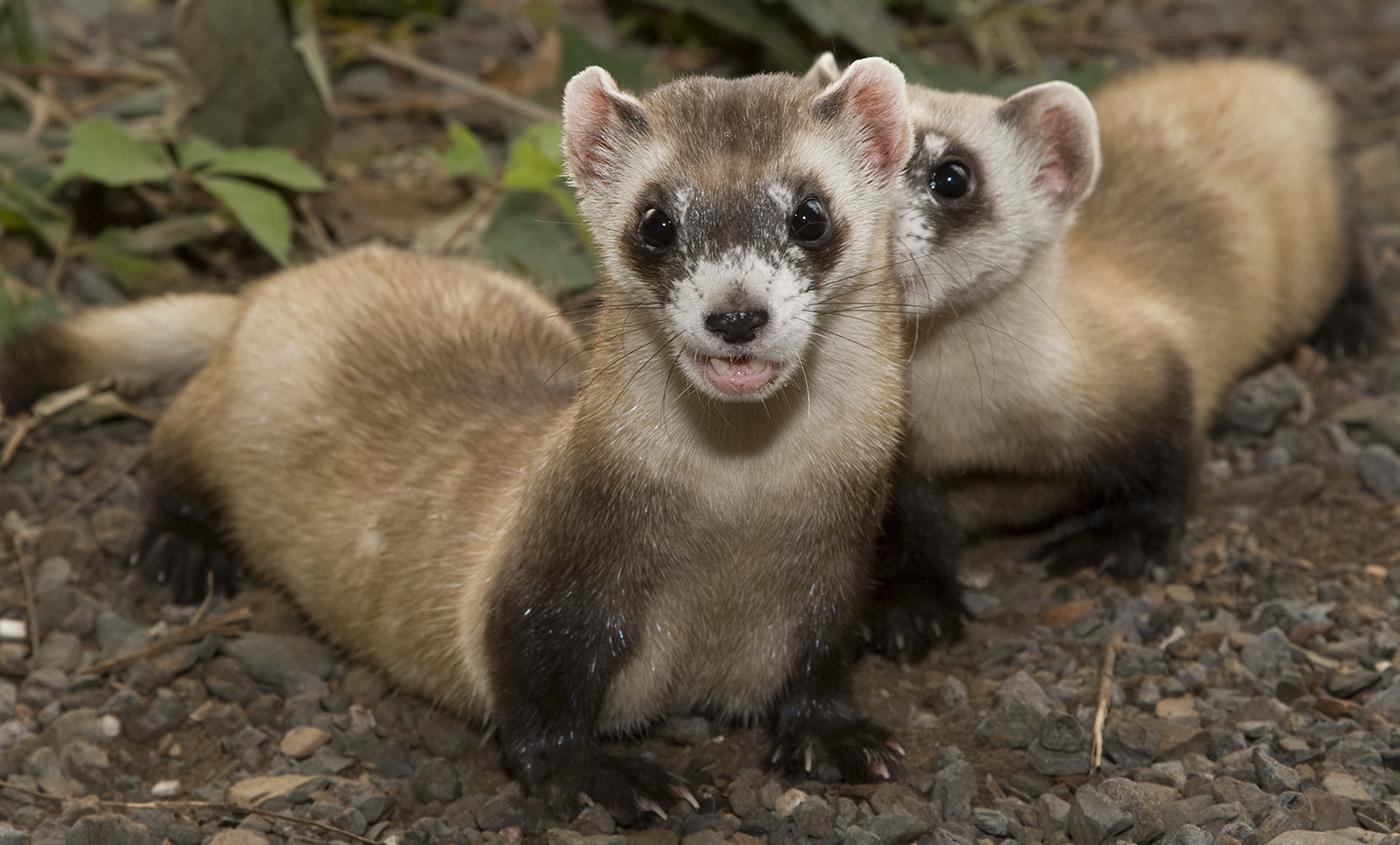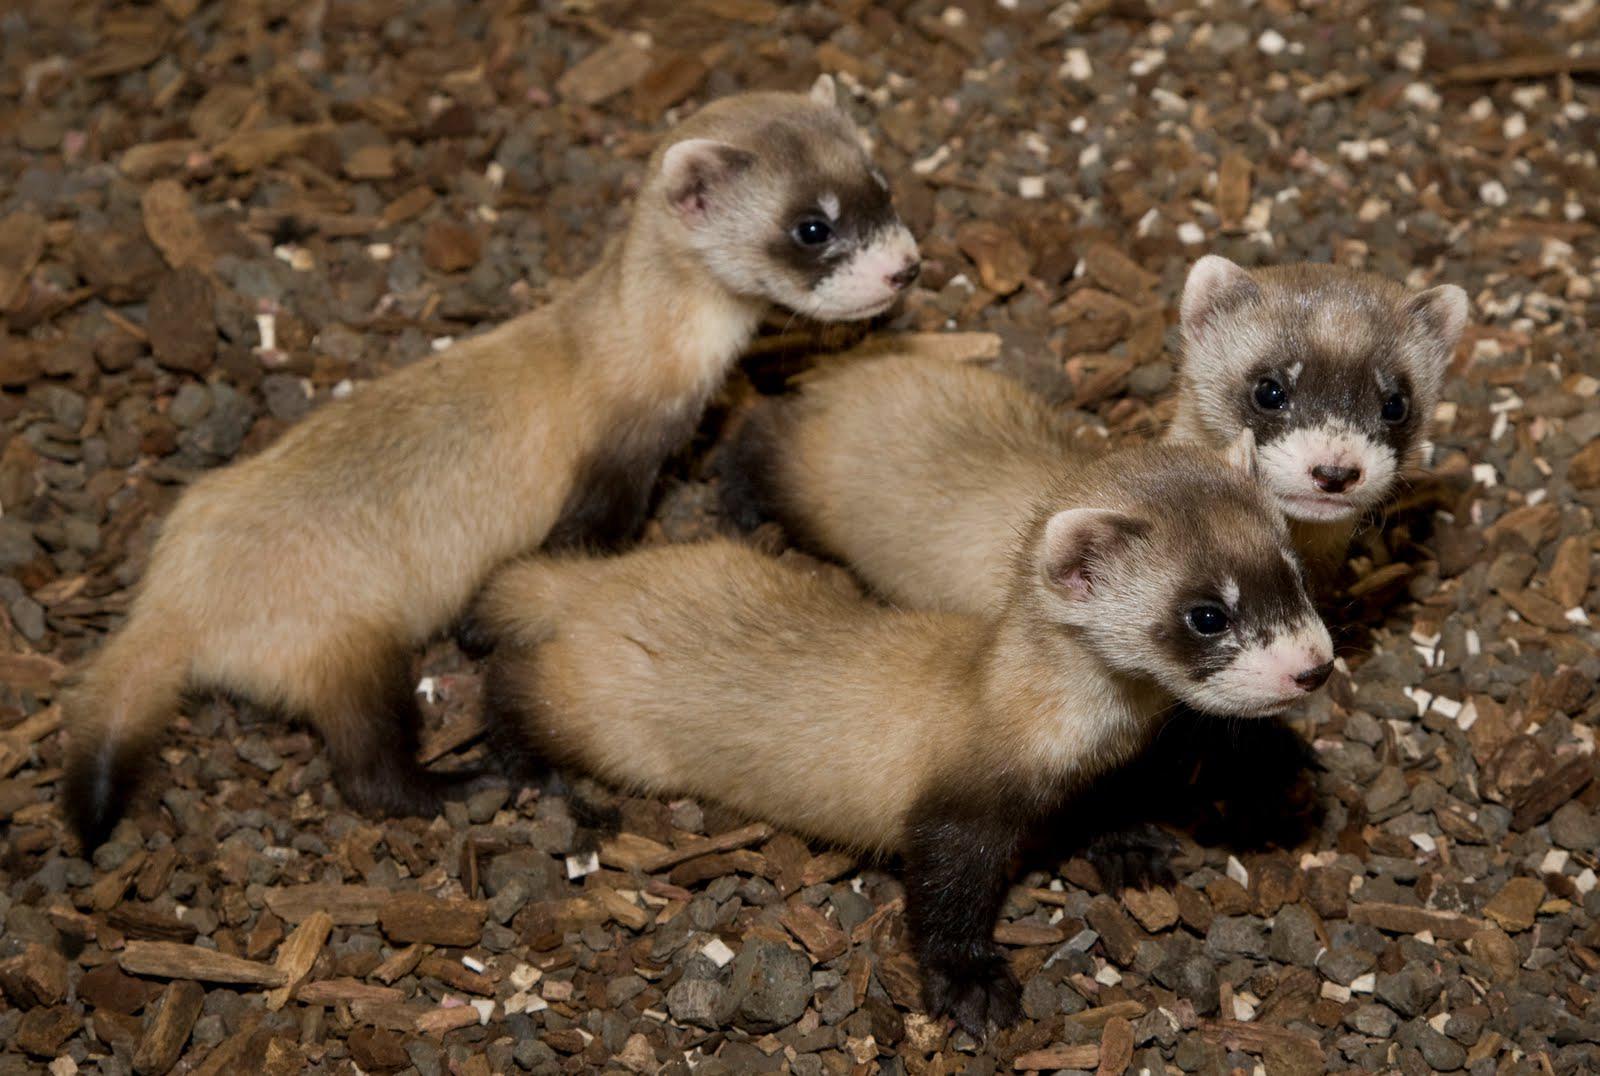The first image is the image on the left, the second image is the image on the right. Assess this claim about the two images: "There are more than five prairie dogs poking up from the ground.". Correct or not? Answer yes or no. No. 